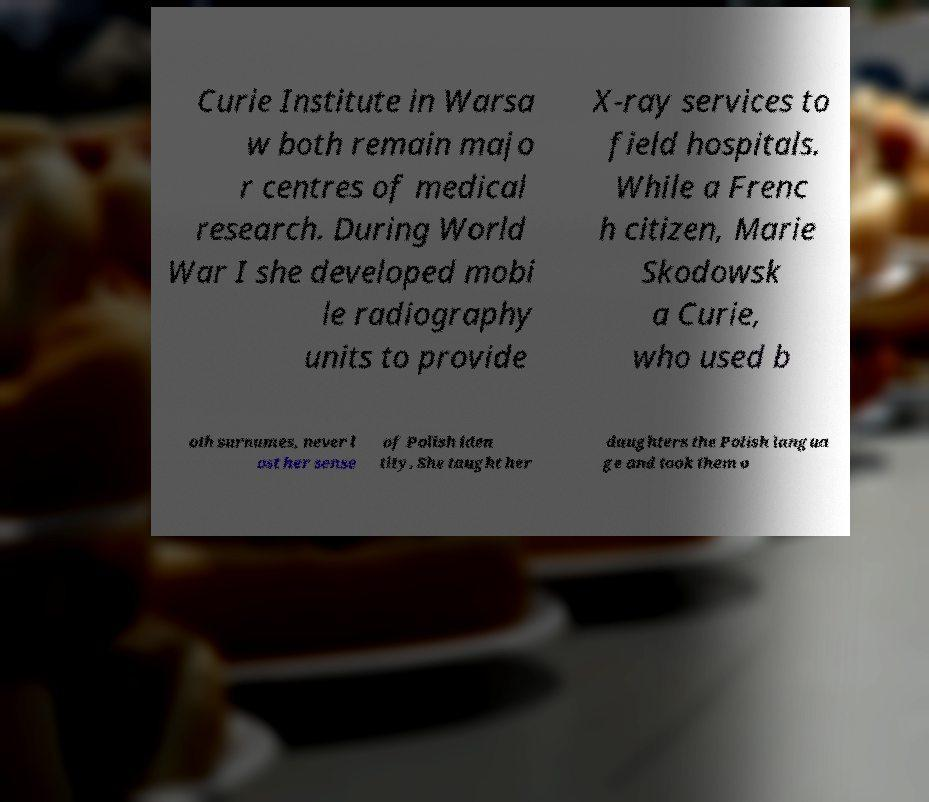Can you accurately transcribe the text from the provided image for me? Curie Institute in Warsa w both remain majo r centres of medical research. During World War I she developed mobi le radiography units to provide X-ray services to field hospitals. While a Frenc h citizen, Marie Skodowsk a Curie, who used b oth surnames, never l ost her sense of Polish iden tity. She taught her daughters the Polish langua ge and took them o 